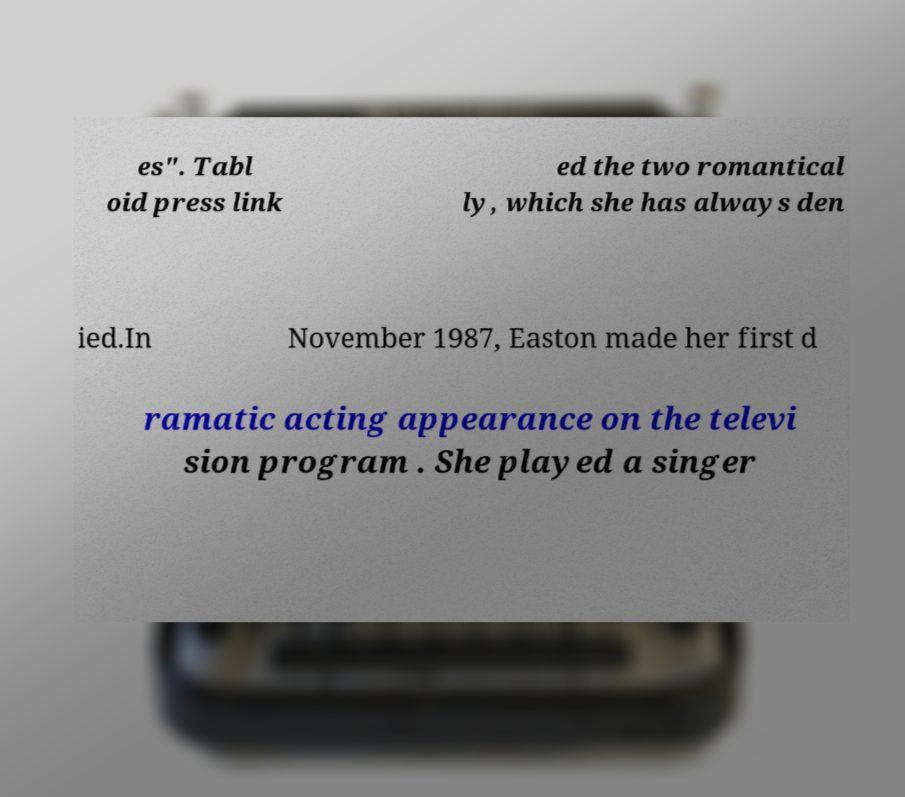What messages or text are displayed in this image? I need them in a readable, typed format. es". Tabl oid press link ed the two romantical ly, which she has always den ied.In November 1987, Easton made her first d ramatic acting appearance on the televi sion program . She played a singer 